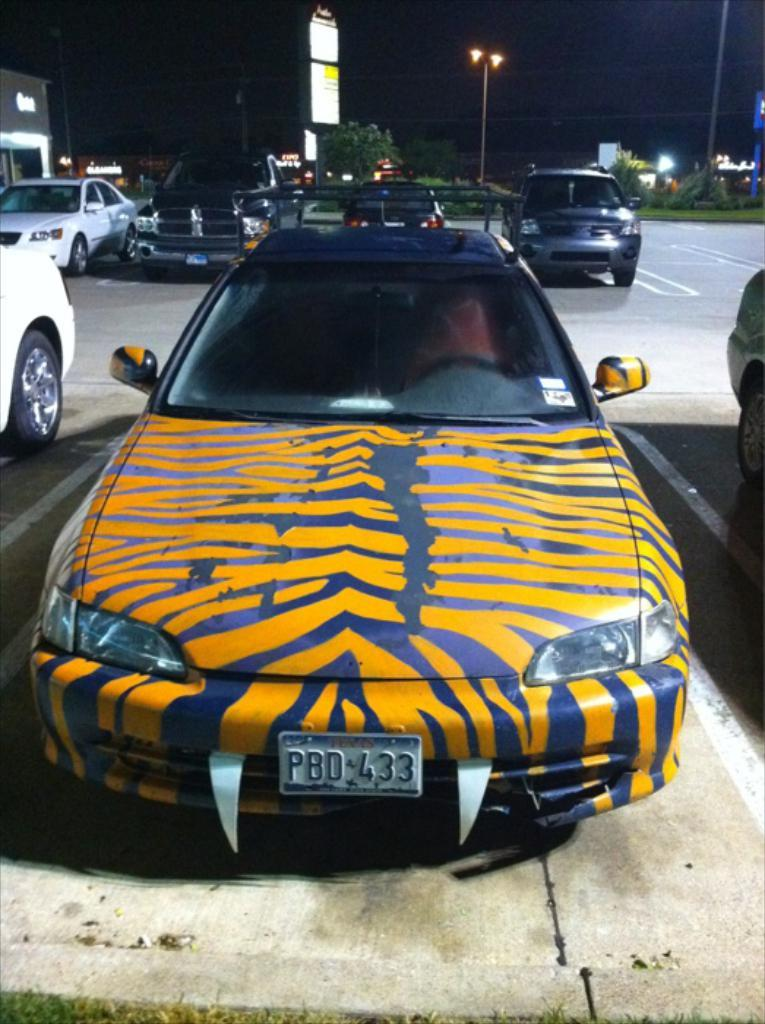<image>
Provide a brief description of the given image. a car that has PBD on the front 